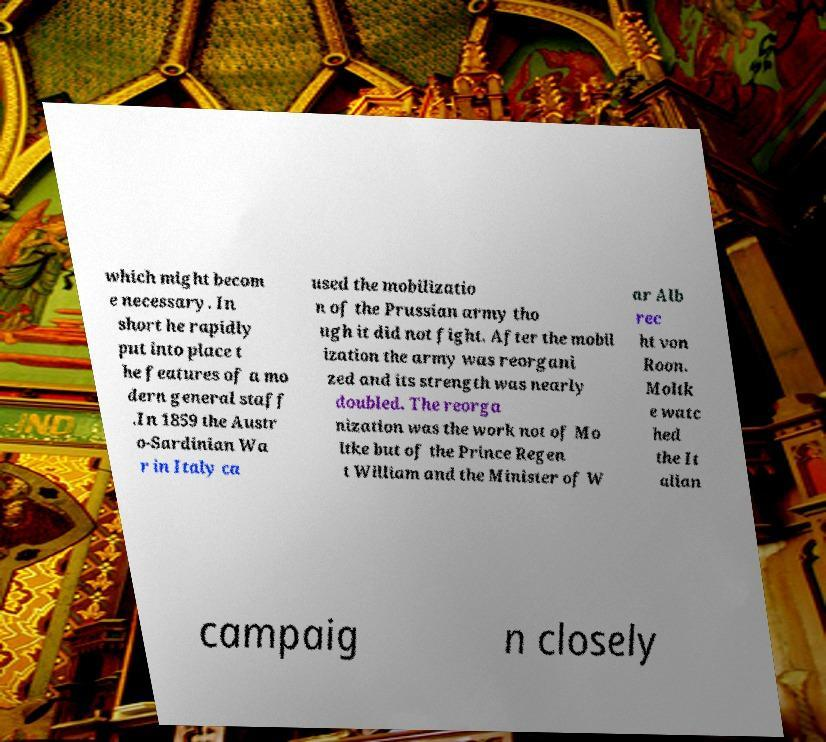Please read and relay the text visible in this image. What does it say? which might becom e necessary. In short he rapidly put into place t he features of a mo dern general staff .In 1859 the Austr o-Sardinian Wa r in Italy ca used the mobilizatio n of the Prussian army tho ugh it did not fight. After the mobil ization the army was reorgani zed and its strength was nearly doubled. The reorga nization was the work not of Mo ltke but of the Prince Regen t William and the Minister of W ar Alb rec ht von Roon. Moltk e watc hed the It alian campaig n closely 